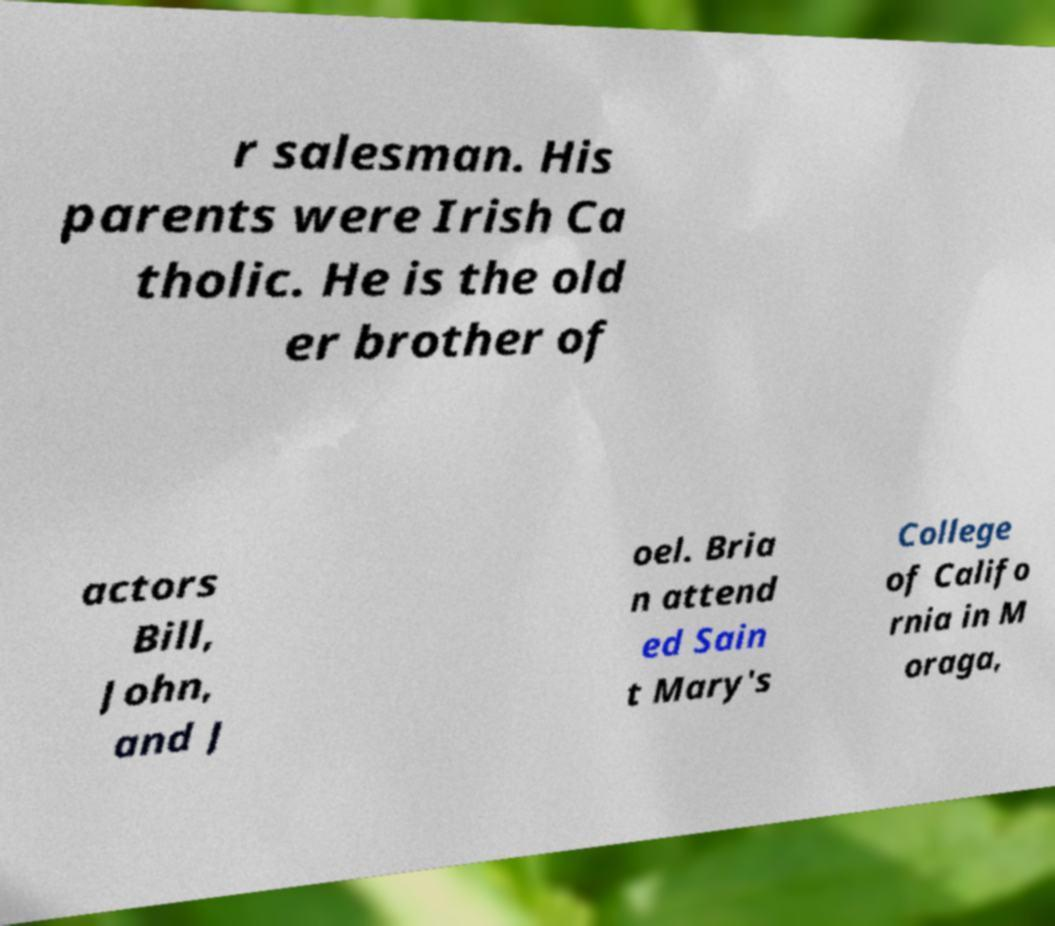For documentation purposes, I need the text within this image transcribed. Could you provide that? r salesman. His parents were Irish Ca tholic. He is the old er brother of actors Bill, John, and J oel. Bria n attend ed Sain t Mary's College of Califo rnia in M oraga, 